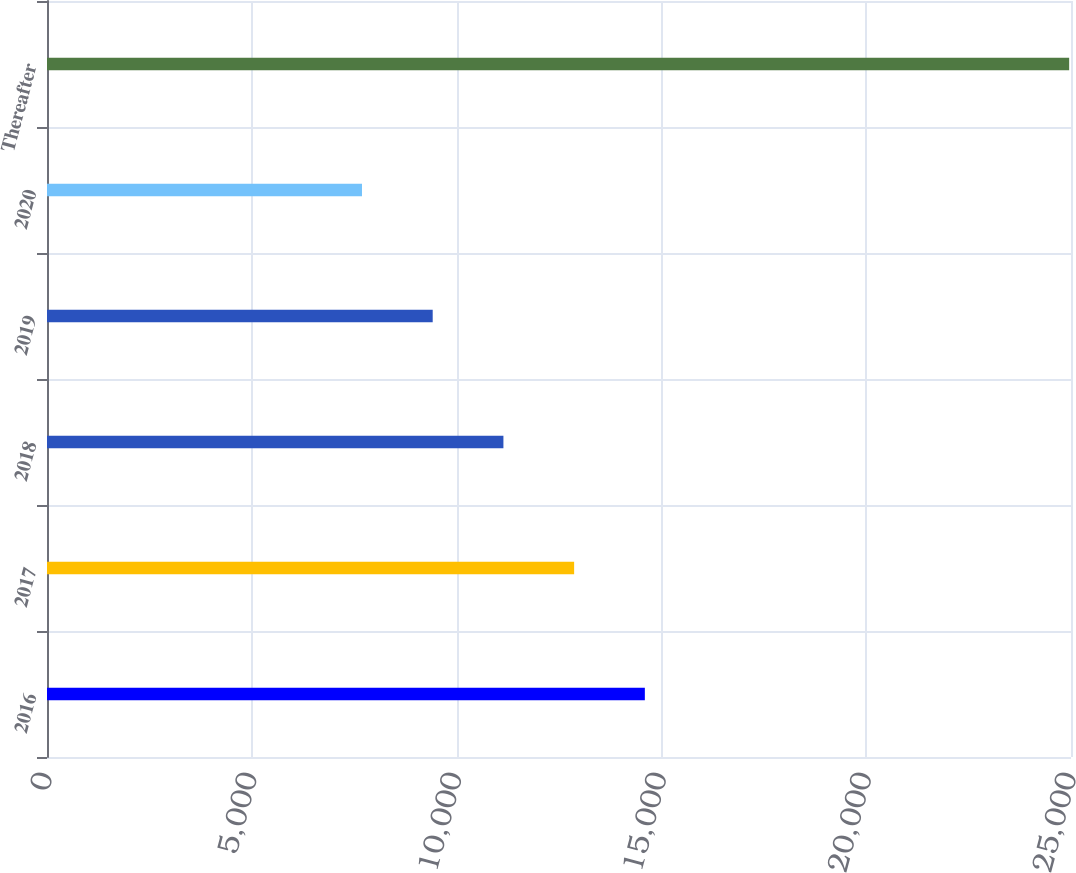Convert chart. <chart><loc_0><loc_0><loc_500><loc_500><bar_chart><fcel>2016<fcel>2017<fcel>2018<fcel>2019<fcel>2020<fcel>Thereafter<nl><fcel>14596<fcel>12869.5<fcel>11143<fcel>9416.5<fcel>7690<fcel>24955<nl></chart> 